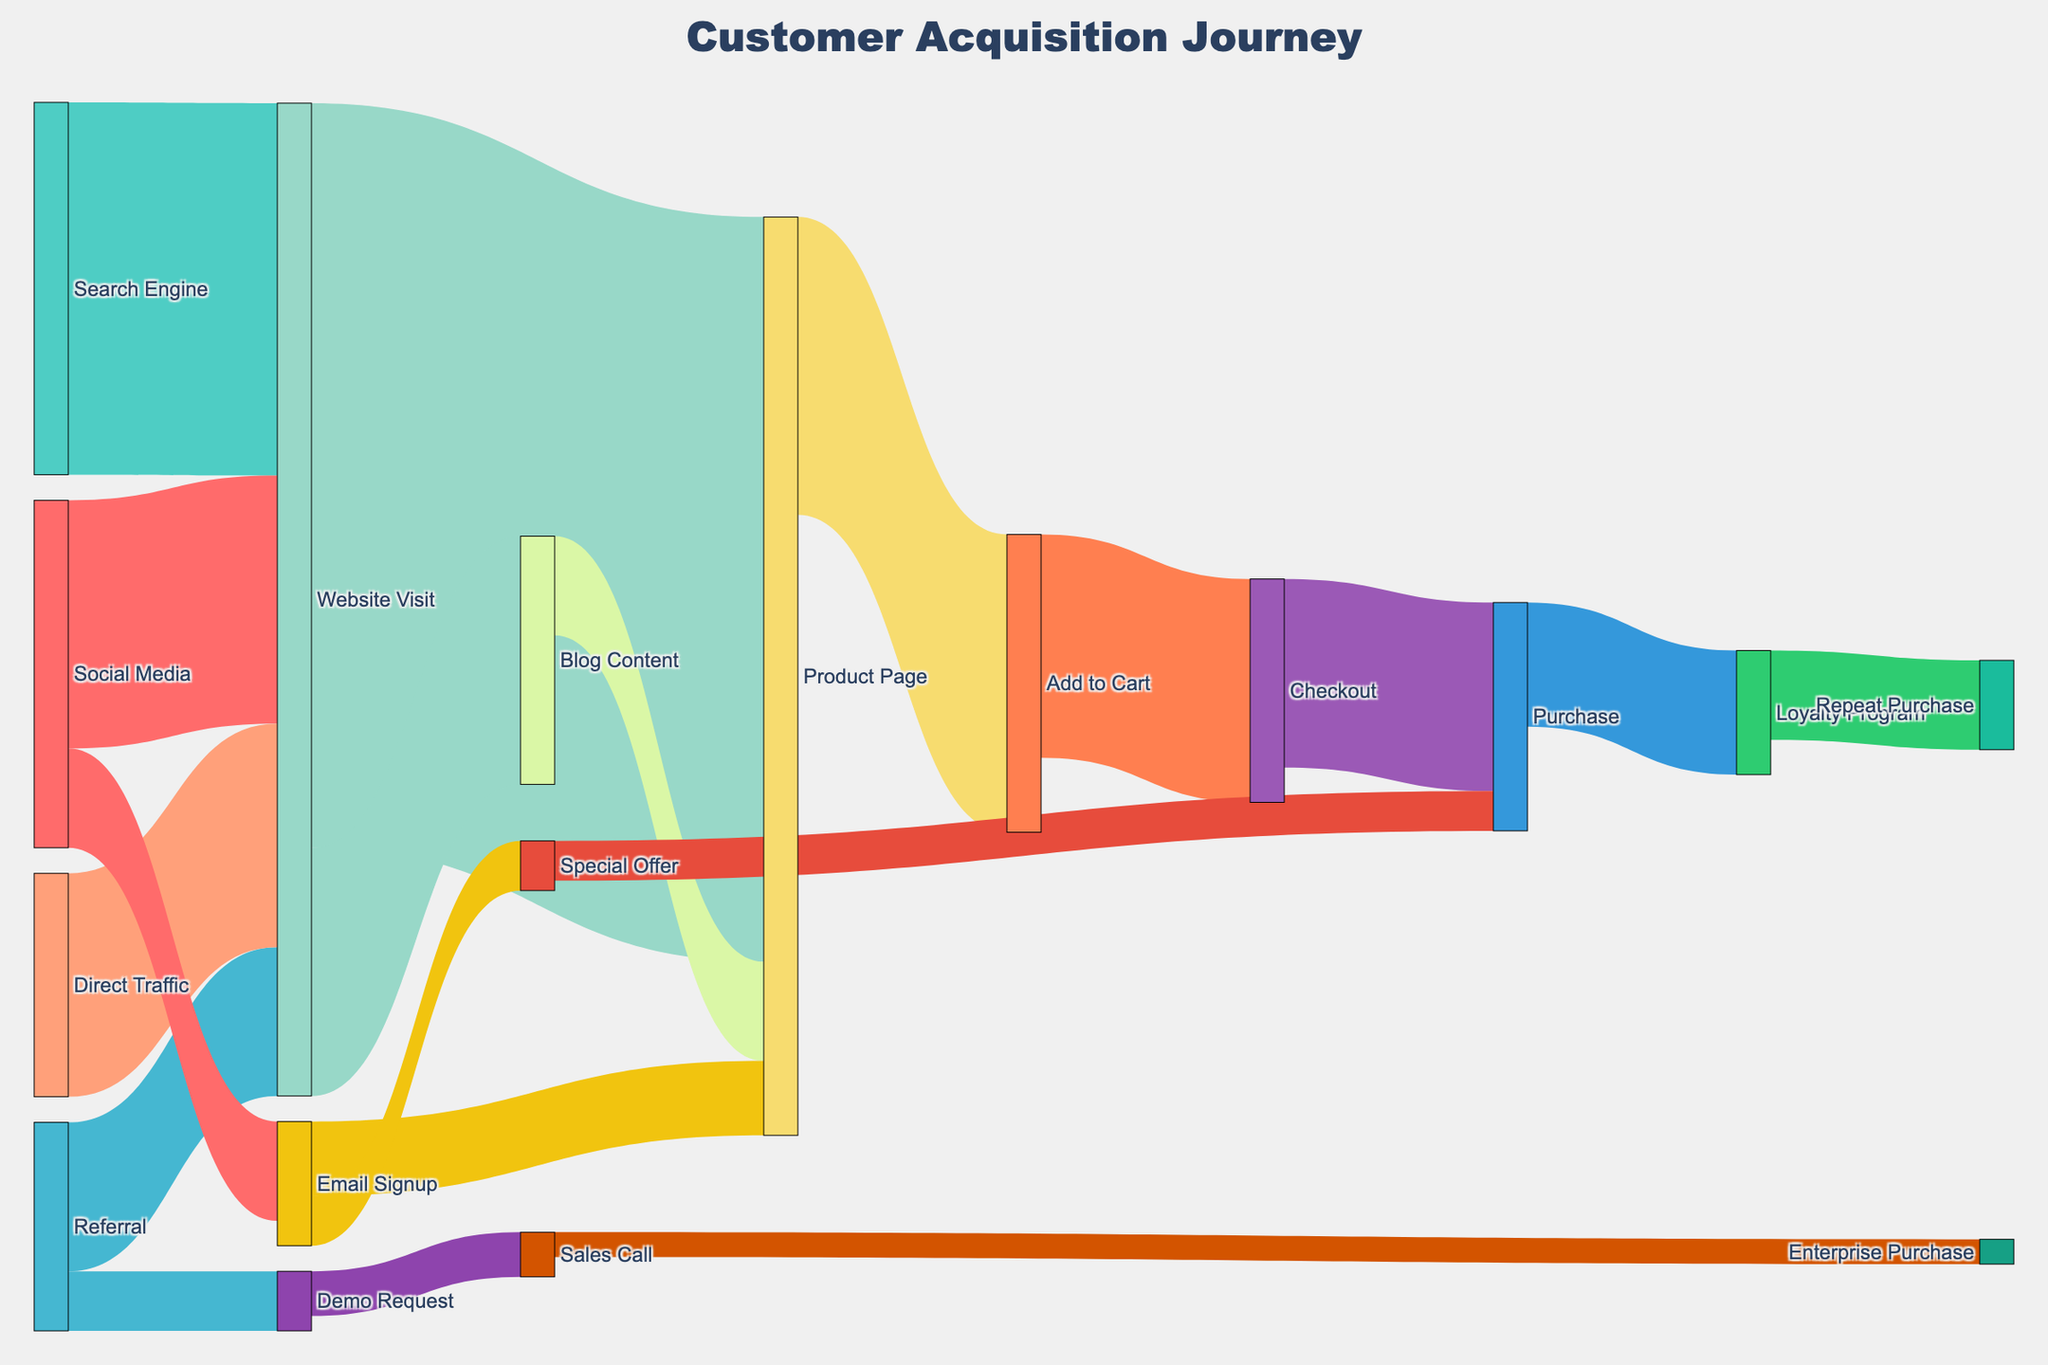What's the title of the figure? The title of the figure is located at the top center of the plot. It reads "Customer Acquisition Journey".
Answer: Customer Acquisition Journey How many customers visited the website from social media? Look at the flow from "Social Media" to "Website Visit". The value associated with this link is 5000.
Answer: 5000 Which marketing channel brought the most visitors to the website? Examine the source nodes that connect to the "Website Visit" target. Compare the values: 5000 from Social Media, 7500 from Search Engine, 3000 from Referral, and 4500 from Direct Traffic. The highest value is 7500 from Search Engine.
Answer: Search Engine What is the total number of customers that reached the Purchase stage from the Checkout stage? Look at the flow from "Checkout" to "Purchase". The value is 3800.
Answer: 3800 How many customers signed up for the email list through social media? Check the flow from "Social Media" to "Email Signup". The value is 2000.
Answer: 2000 Calculate the total number of customers that ended up on the Product Page. Sum the values of flows leading to the Product Page: 15000 from Website Visit, 2000 from Blog Content, and 1500 from Email Signup. 15000 + 2000 + 1500 = 18500.
Answer: 18500 What is the difference in the number of customers between those who requested a demo and those who made an enterprise purchase? Look at flows for "Demo Request" (1200) and "Enterprise Purchase" (500). Calculate the difference: 1200 - 500 = 700.
Answer: 700 Which flow has the smallest value, and what is it? Identify the smallest value among all flows. The smallest value is from "Sales Call" to "Enterprise Purchase" which is 500.
Answer: Sales Call to Enterprise Purchase, 500 From which stage does Checkout receive its customers? Identify the source node for the "Checkout" target. The source node is "Add to Cart".
Answer: Add to Cart How many customers ended up in the Loyalty Program after making a purchase? Examine the flow between "Purchase" and "Loyalty Program". The value is 2500.
Answer: 2500 